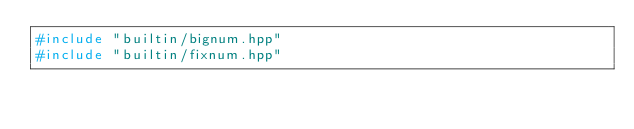Convert code to text. <code><loc_0><loc_0><loc_500><loc_500><_C++_>#include "builtin/bignum.hpp"
#include "builtin/fixnum.hpp"</code> 